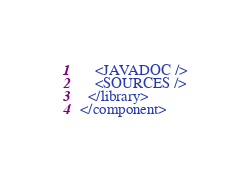<code> <loc_0><loc_0><loc_500><loc_500><_XML_>    <JAVADOC />
    <SOURCES />
  </library>
</component></code> 